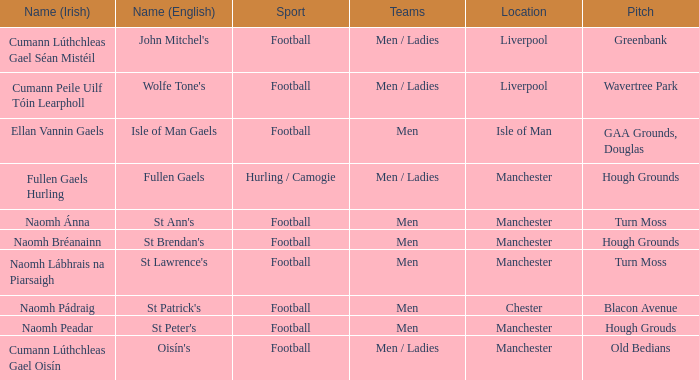What is the Location of the Old Bedians Pitch? Manchester. 